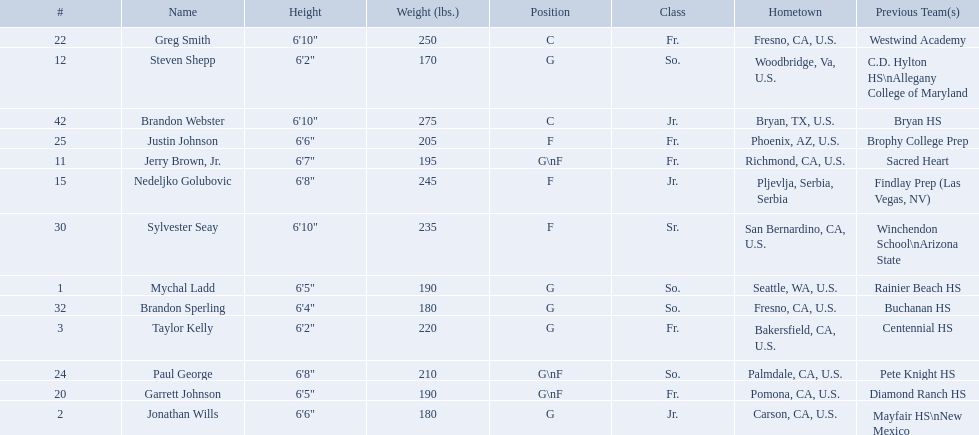Who are all the players in the 2009-10 fresno state bulldogs men's basketball team? Mychal Ladd, Jonathan Wills, Taylor Kelly, Jerry Brown, Jr., Steven Shepp, Nedeljko Golubovic, Garrett Johnson, Greg Smith, Paul George, Justin Johnson, Sylvester Seay, Brandon Sperling, Brandon Webster. Of these players, who are the ones who play forward? Jerry Brown, Jr., Nedeljko Golubovic, Garrett Johnson, Paul George, Justin Johnson, Sylvester Seay. Of these players, which ones only play forward and no other position? Nedeljko Golubovic, Justin Johnson, Sylvester Seay. Of these players, who is the shortest? Justin Johnson. Which players are forwards? Nedeljko Golubovic, Paul George, Justin Johnson, Sylvester Seay. What are the heights of these players? Nedeljko Golubovic, 6'8", Paul George, 6'8", Justin Johnson, 6'6", Sylvester Seay, 6'10". Of these players, who is the shortest? Justin Johnson. 